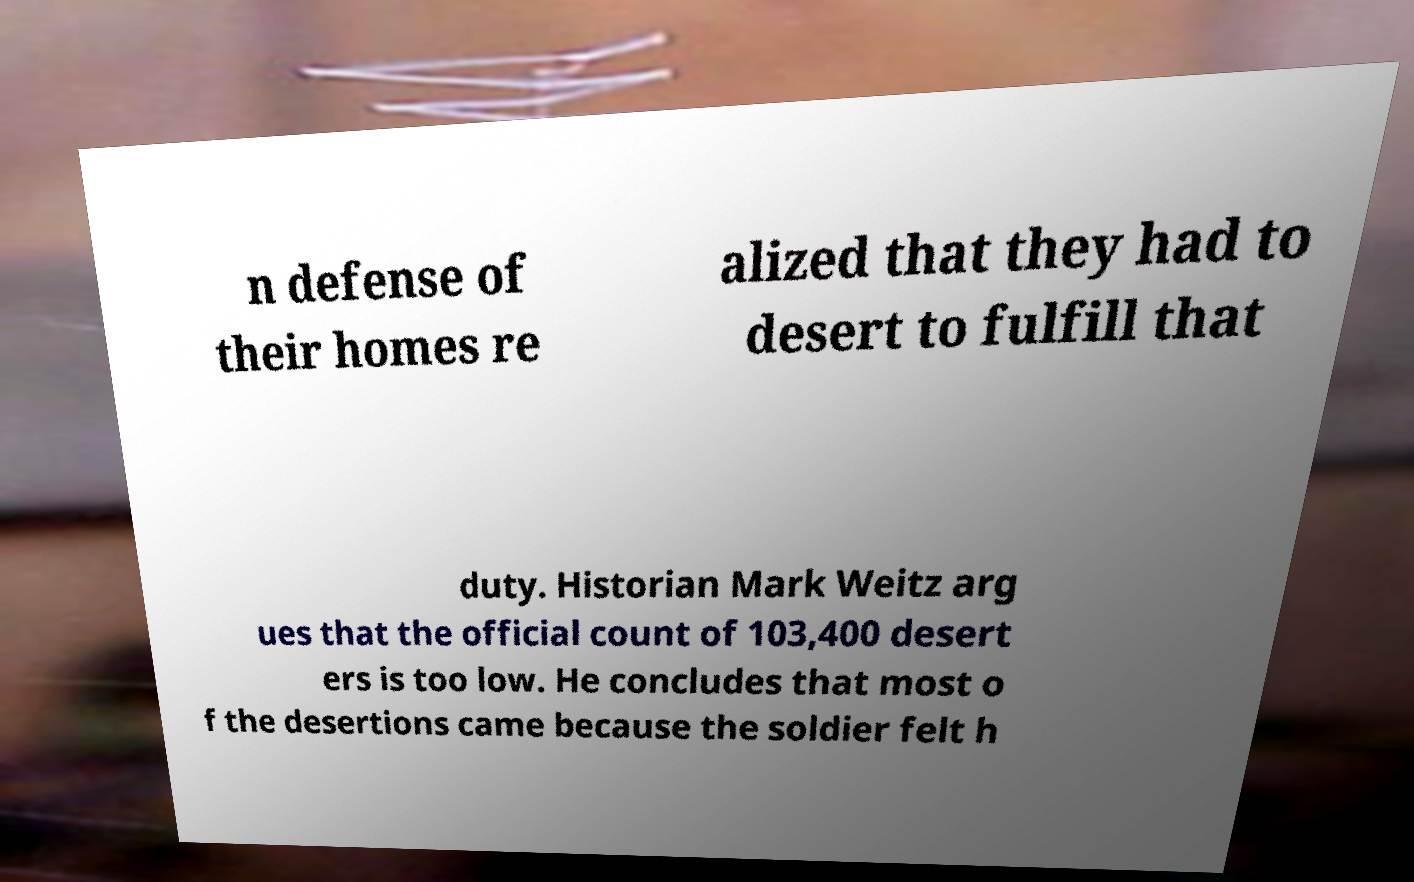There's text embedded in this image that I need extracted. Can you transcribe it verbatim? n defense of their homes re alized that they had to desert to fulfill that duty. Historian Mark Weitz arg ues that the official count of 103,400 desert ers is too low. He concludes that most o f the desertions came because the soldier felt h 